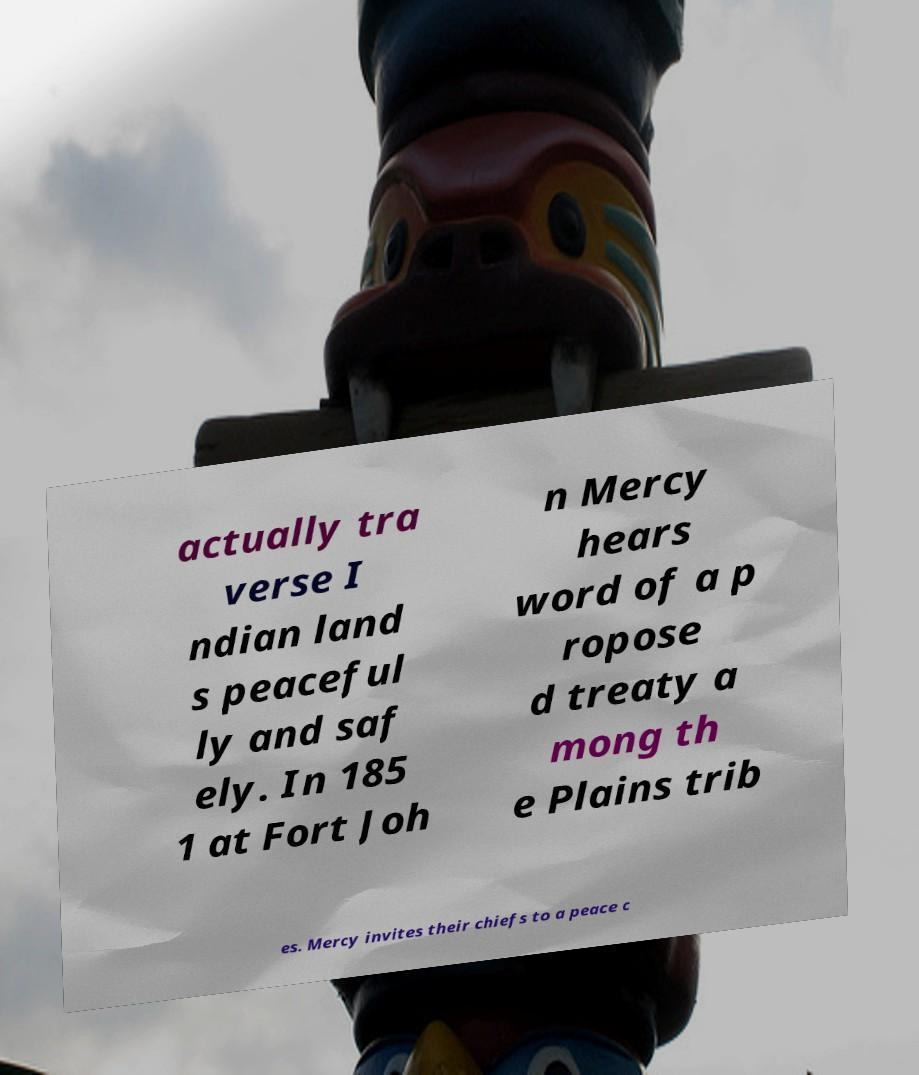I need the written content from this picture converted into text. Can you do that? actually tra verse I ndian land s peaceful ly and saf ely. In 185 1 at Fort Joh n Mercy hears word of a p ropose d treaty a mong th e Plains trib es. Mercy invites their chiefs to a peace c 